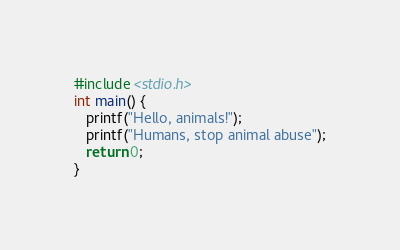Convert code to text. <code><loc_0><loc_0><loc_500><loc_500><_C_>#include <stdio.h>
int main() {
   printf("Hello, animals!");
   printf("Humans, stop animal abuse");
   return 0;
}
</code> 